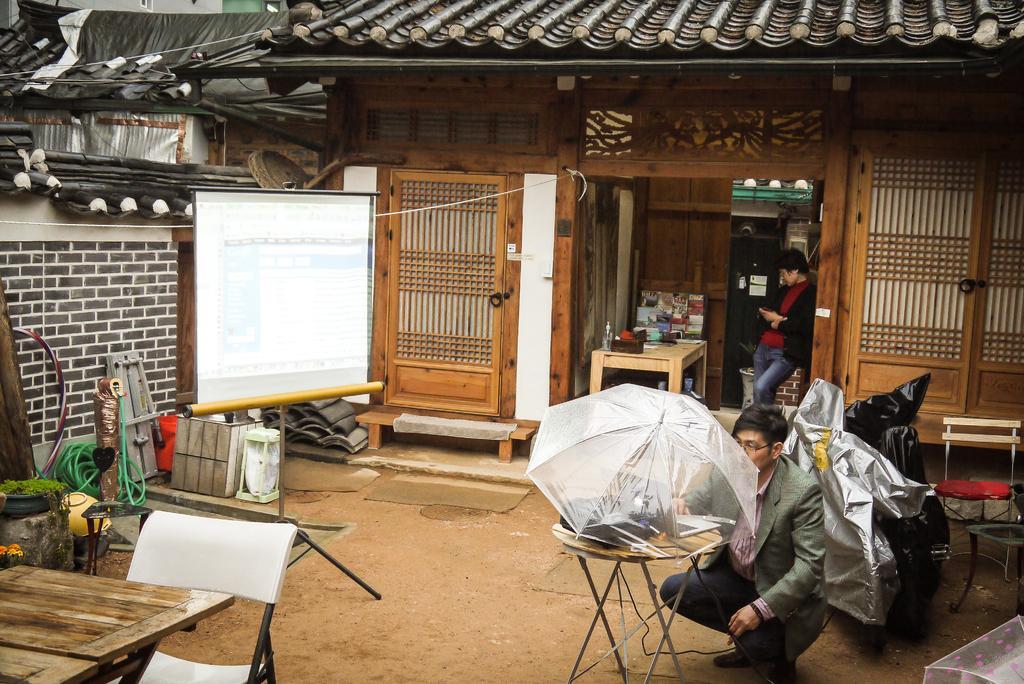Can you describe this image briefly? In this picture there is a view of the hall. In the front there is a man wearing a grey color coat sitting on the ground and setting the camera with the transparent umbrella on the top. Behind there is a girl wearing a black color coat is looking into the phone. In the background we can see the house with wooden windows and doors. On the left side there is a white projector screen and beside a dining table with white color chairs. 